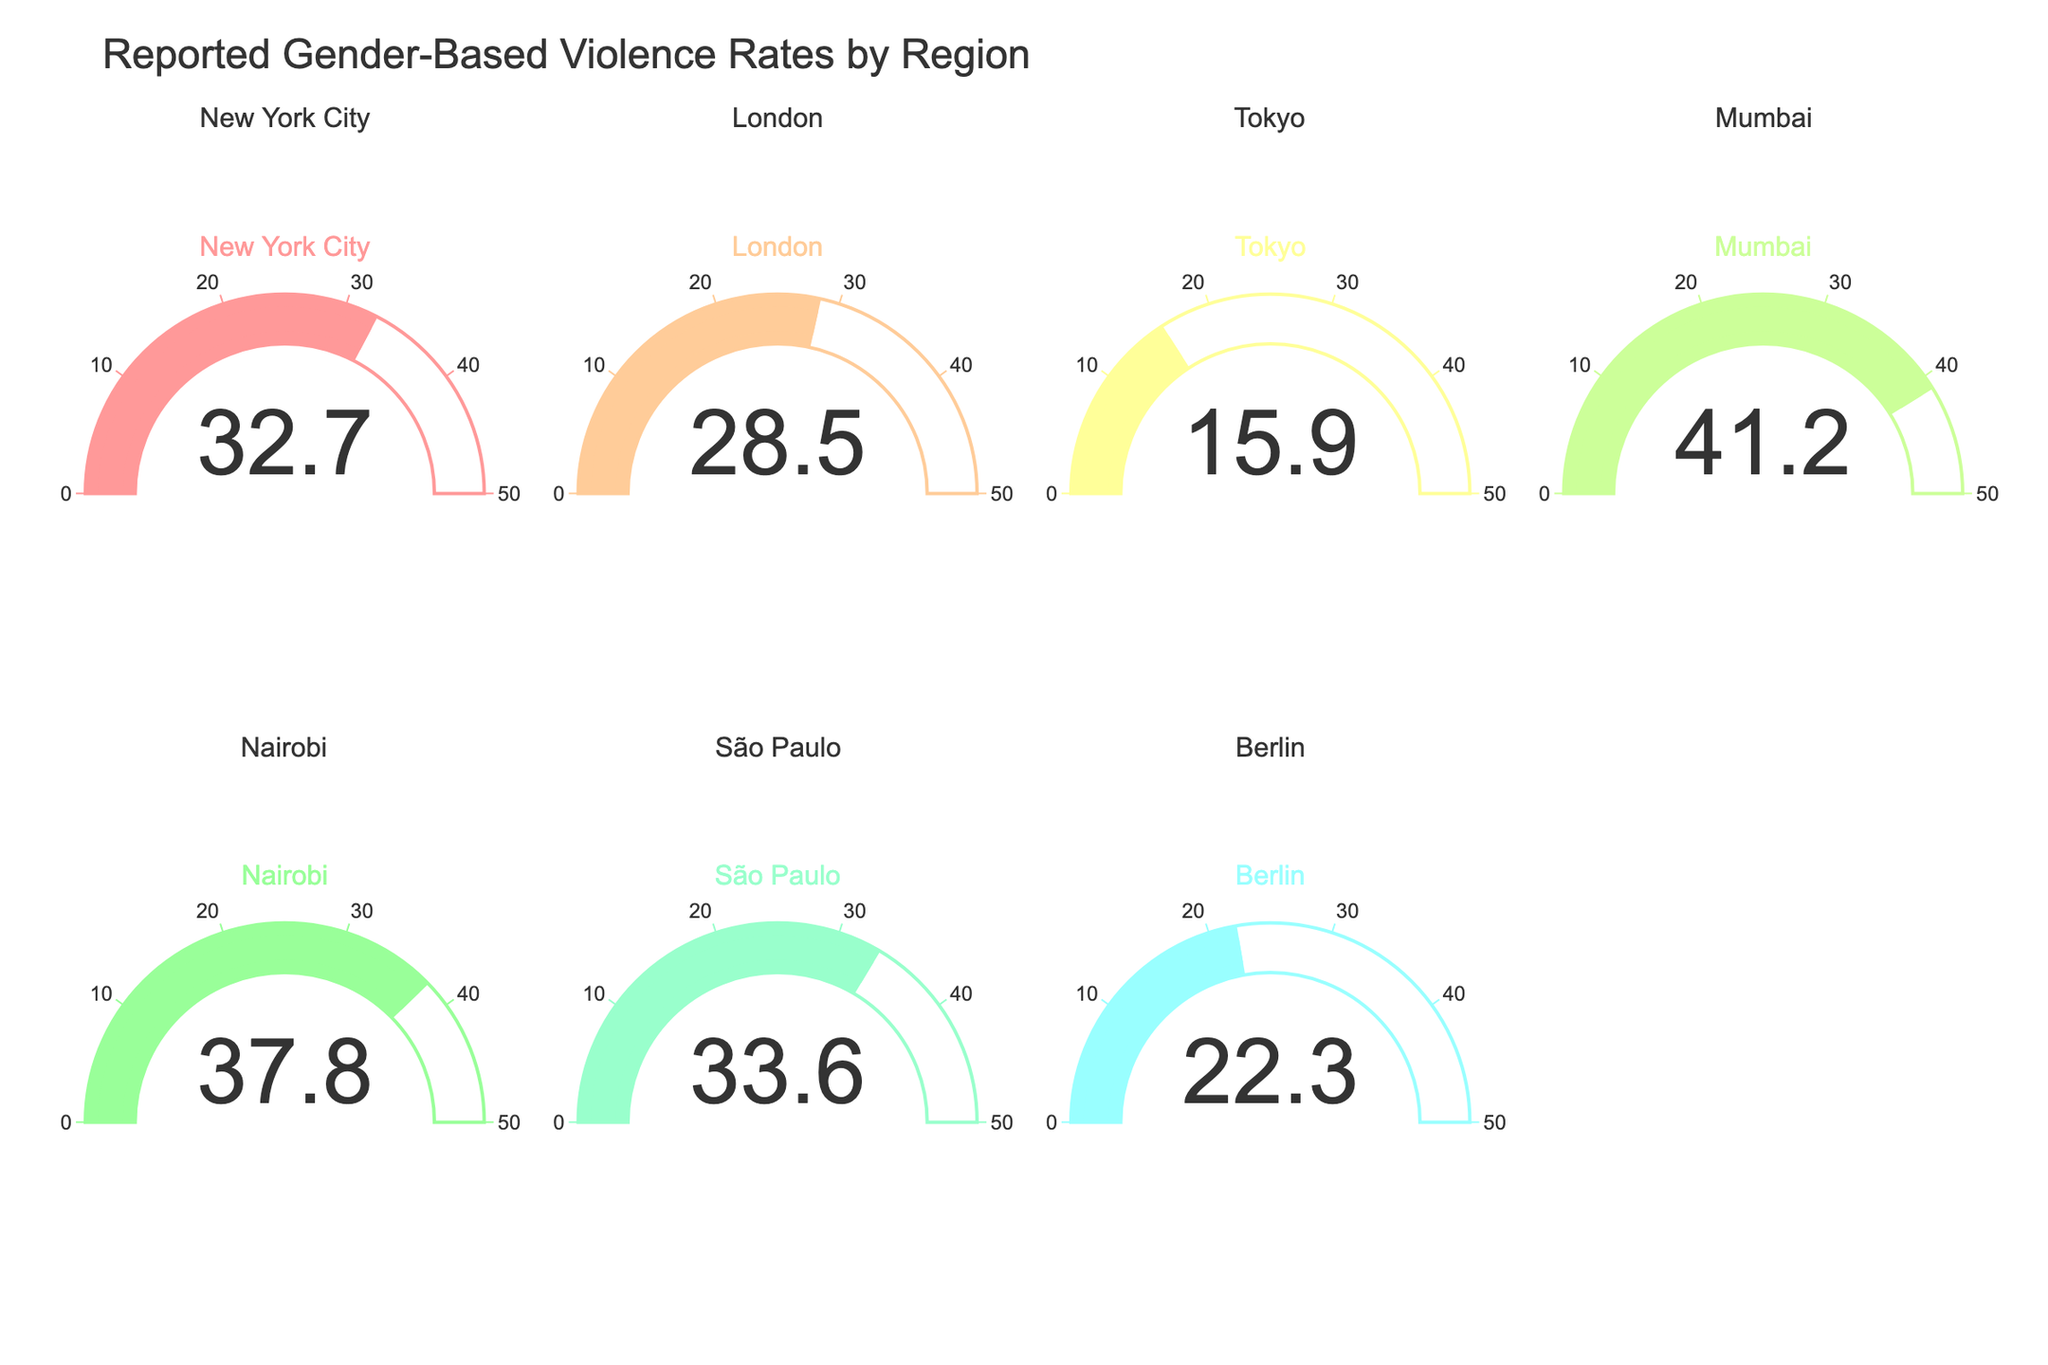Which region has the highest reported rate of gender-based violence? By observing the gauge charts, the highest single value can be identified. Mumbai shows the highest reported rate of 41.2.
Answer: Mumbai Which region has the lowest reported rate of gender-based violence? By observing the gauge charts, Tokyo has the lowest reported rate of 15.9.
Answer: Tokyo What is the reported rate of gender-based violence in New York City? By looking at the specific gauge for New York City, it shows a value of 32.7.
Answer: 32.7 Is the reported rate of gender-based violence in Nairobi greater than that in London? By comparing the gauges for Nairobi and London, Nairobi's rate is 37.8 which is greater than London’s rate of 28.5.
Answer: Yes What is the average reported rate of gender-based violence across all regions? Summing all rates (32.7 + 28.5 + 15.9 + 41.2 + 37.8 + 33.6 + 22.3) and dividing by the number of regions (7), the average rate is approximately 30.28.
Answer: 30.28 How much higher is the reported rate of gender-based violence in Mumbai compared to Berlin? By subtracting Berlin’s rate (22.3) from Mumbai’s rate (41.2), the difference is 18.9.
Answer: 18.9 Which regions reported a gender-based violence rate above 30? By checking individual gauge values, New York City (32.7), Mumbai (41.2), Nairobi (37.8), and São Paulo (33.6) have rates above 30.
Answer: New York City, Mumbai, Nairobi, São Paulo What is the median reported rate of gender-based violence? Ordering the rates (15.9, 22.3, 28.5, 32.7, 33.6, 37.8, 41.2), the median value is the middle one, which is 32.7.
Answer: 32.7 Does any region have a reported gender-based violence rate between 20 and 25? By checking the gauges, Berlin has a rate of 22.3, which falls within the range of 20 to 25.
Answer: Yes Which regions have a reported rate of gender-based violence that is less than 25? By checking the gauges, both Tokyo (15.9) and Berlin (22.3) have rates less than 25.
Answer: Tokyo, Berlin 